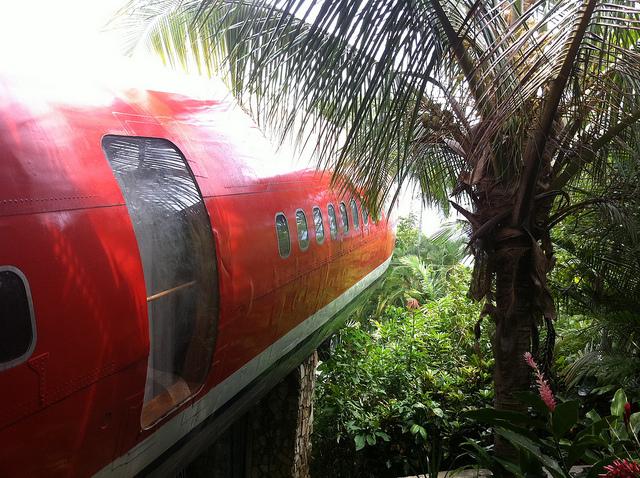What kind of tree is that?
Give a very brief answer. Palm. Could this be a tropical region?
Keep it brief. Yes. What color is on the left building?
Concise answer only. Red. 